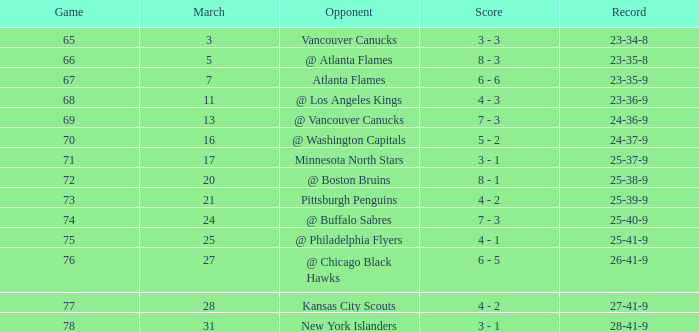I'm looking to parse the entire table for insights. Could you assist me with that? {'header': ['Game', 'March', 'Opponent', 'Score', 'Record'], 'rows': [['65', '3', 'Vancouver Canucks', '3 - 3', '23-34-8'], ['66', '5', '@ Atlanta Flames', '8 - 3', '23-35-8'], ['67', '7', 'Atlanta Flames', '6 - 6', '23-35-9'], ['68', '11', '@ Los Angeles Kings', '4 - 3', '23-36-9'], ['69', '13', '@ Vancouver Canucks', '7 - 3', '24-36-9'], ['70', '16', '@ Washington Capitals', '5 - 2', '24-37-9'], ['71', '17', 'Minnesota North Stars', '3 - 1', '25-37-9'], ['72', '20', '@ Boston Bruins', '8 - 1', '25-38-9'], ['73', '21', 'Pittsburgh Penguins', '4 - 2', '25-39-9'], ['74', '24', '@ Buffalo Sabres', '7 - 3', '25-40-9'], ['75', '25', '@ Philadelphia Flyers', '4 - 1', '25-41-9'], ['76', '27', '@ Chicago Black Hawks', '6 - 5', '26-41-9'], ['77', '28', 'Kansas City Scouts', '4 - 2', '27-41-9'], ['78', '31', 'New York Islanders', '3 - 1', '28-41-9']]} What was the score when they had a 25-41-9 record? 4 - 1. 